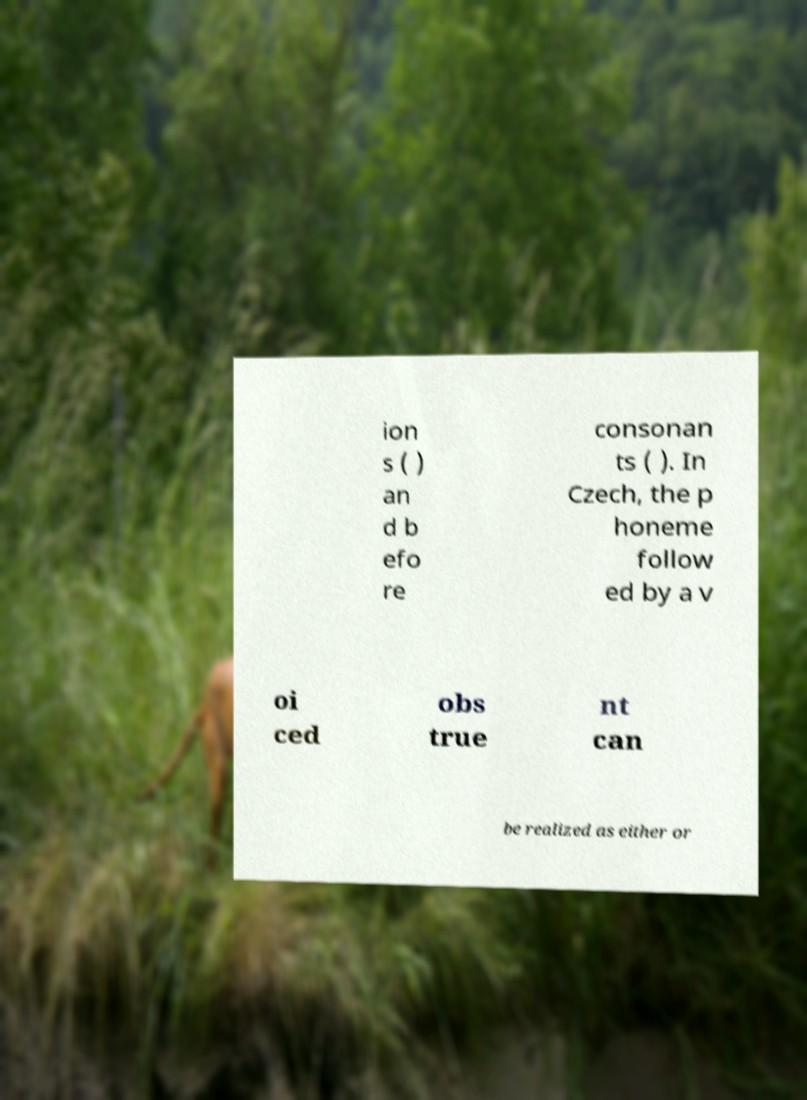Please identify and transcribe the text found in this image. ion s ( ) an d b efo re consonan ts ( ). In Czech, the p honeme follow ed by a v oi ced obs true nt can be realized as either or 